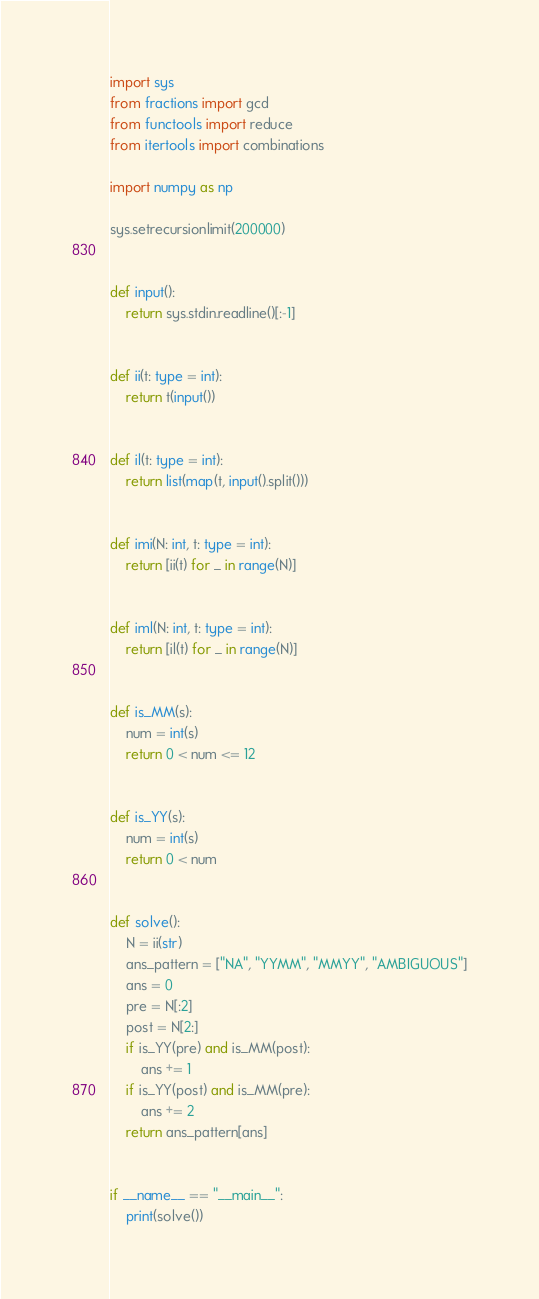Convert code to text. <code><loc_0><loc_0><loc_500><loc_500><_Python_>import sys
from fractions import gcd
from functools import reduce
from itertools import combinations

import numpy as np

sys.setrecursionlimit(200000)


def input():
    return sys.stdin.readline()[:-1]


def ii(t: type = int):
    return t(input())


def il(t: type = int):
    return list(map(t, input().split()))


def imi(N: int, t: type = int):
    return [ii(t) for _ in range(N)]


def iml(N: int, t: type = int):
    return [il(t) for _ in range(N)]


def is_MM(s):
    num = int(s)
    return 0 < num <= 12


def is_YY(s):
    num = int(s)
    return 0 < num


def solve():
    N = ii(str)
    ans_pattern = ["NA", "YYMM", "MMYY", "AMBIGUOUS"]
    ans = 0
    pre = N[:2]
    post = N[2:]
    if is_YY(pre) and is_MM(post):
        ans += 1
    if is_YY(post) and is_MM(pre):
        ans += 2
    return ans_pattern[ans]


if __name__ == "__main__":
    print(solve())
</code> 